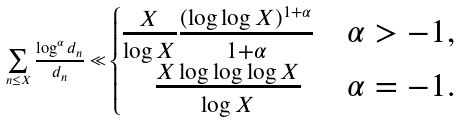<formula> <loc_0><loc_0><loc_500><loc_500>\sum _ { n \leq X } \frac { \log ^ { \alpha } d _ { n } } { d _ { n } } \ll \begin{cases} \frac { X } { \log X } \frac { ( \log \log X ) ^ { 1 + \alpha } } { 1 + \alpha } & \alpha > - 1 , \\ \quad \frac { X \log \log \log X } { \log X } & \alpha = - 1 . \end{cases}</formula> 